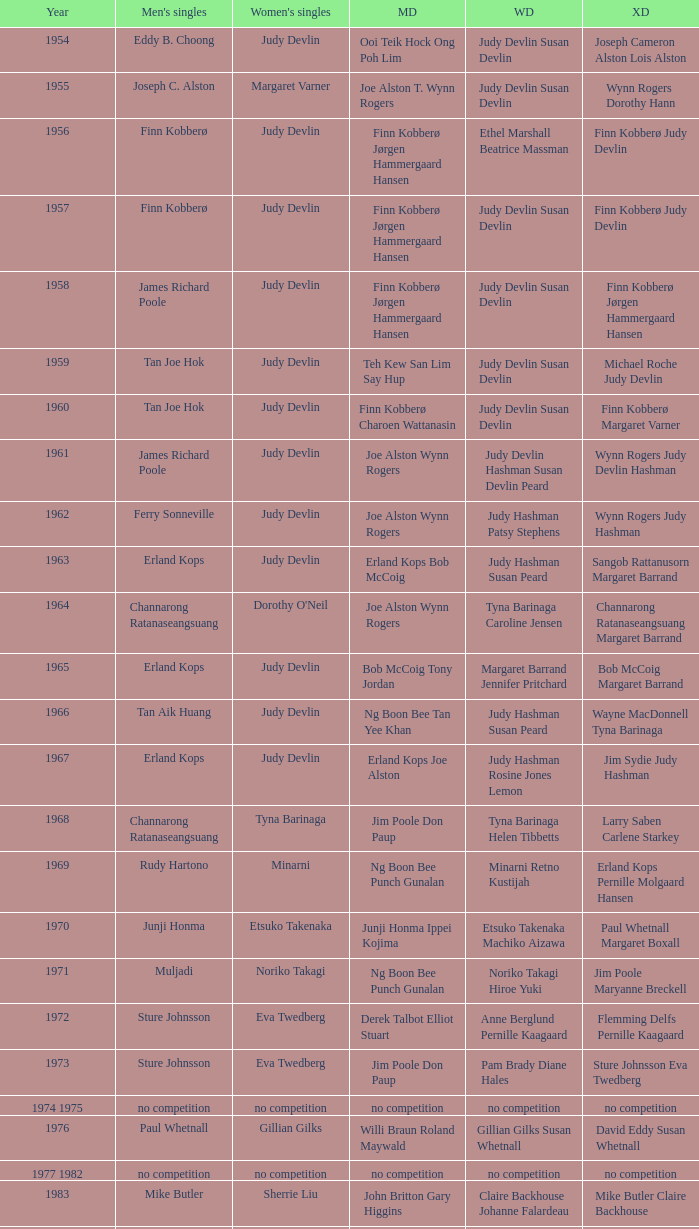Who was the women's singles champion in 1984? Luo Yun. 